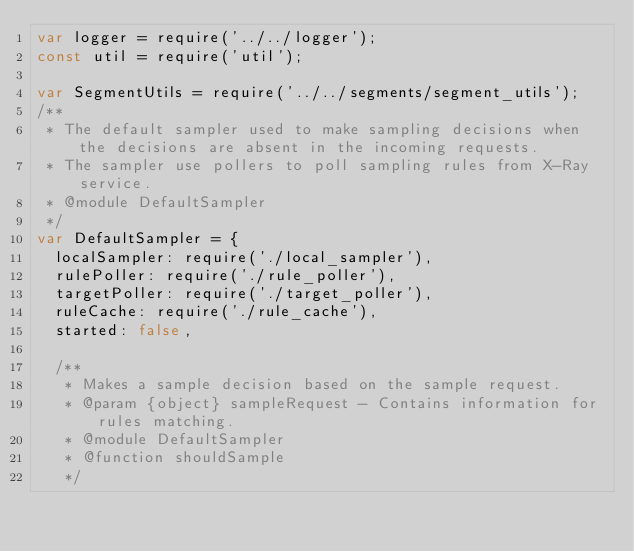<code> <loc_0><loc_0><loc_500><loc_500><_JavaScript_>var logger = require('../../logger');
const util = require('util');

var SegmentUtils = require('../../segments/segment_utils');
/**
 * The default sampler used to make sampling decisions when the decisions are absent in the incoming requests.
 * The sampler use pollers to poll sampling rules from X-Ray service.
 * @module DefaultSampler
 */
var DefaultSampler = {
  localSampler: require('./local_sampler'),
  rulePoller: require('./rule_poller'),
  targetPoller: require('./target_poller'),
  ruleCache: require('./rule_cache'),
  started: false,

  /**
   * Makes a sample decision based on the sample request.
   * @param {object} sampleRequest - Contains information for rules matching.
   * @module DefaultSampler
   * @function shouldSample
   */</code> 